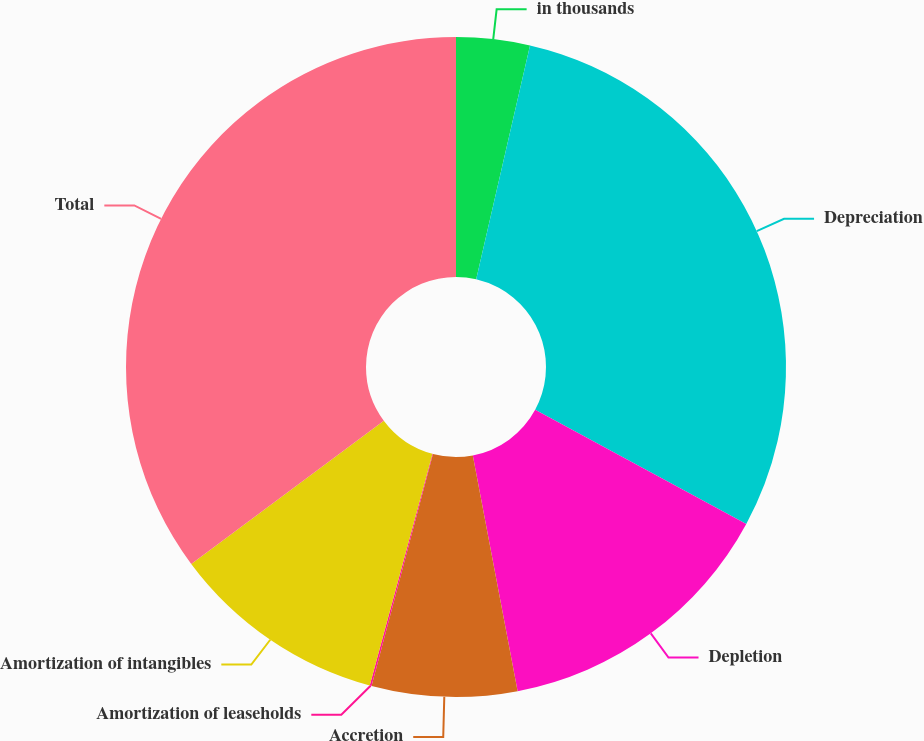<chart> <loc_0><loc_0><loc_500><loc_500><pie_chart><fcel>in thousands<fcel>Depreciation<fcel>Depletion<fcel>Accretion<fcel>Amortization of leaseholds<fcel>Amortization of intangibles<fcel>Total<nl><fcel>3.6%<fcel>29.29%<fcel>14.12%<fcel>7.11%<fcel>0.09%<fcel>10.61%<fcel>35.18%<nl></chart> 